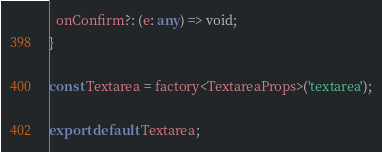Convert code to text. <code><loc_0><loc_0><loc_500><loc_500><_TypeScript_>  onConfirm?: (e: any) => void;
}

const Textarea = factory<TextareaProps>('textarea');

export default Textarea;
</code> 